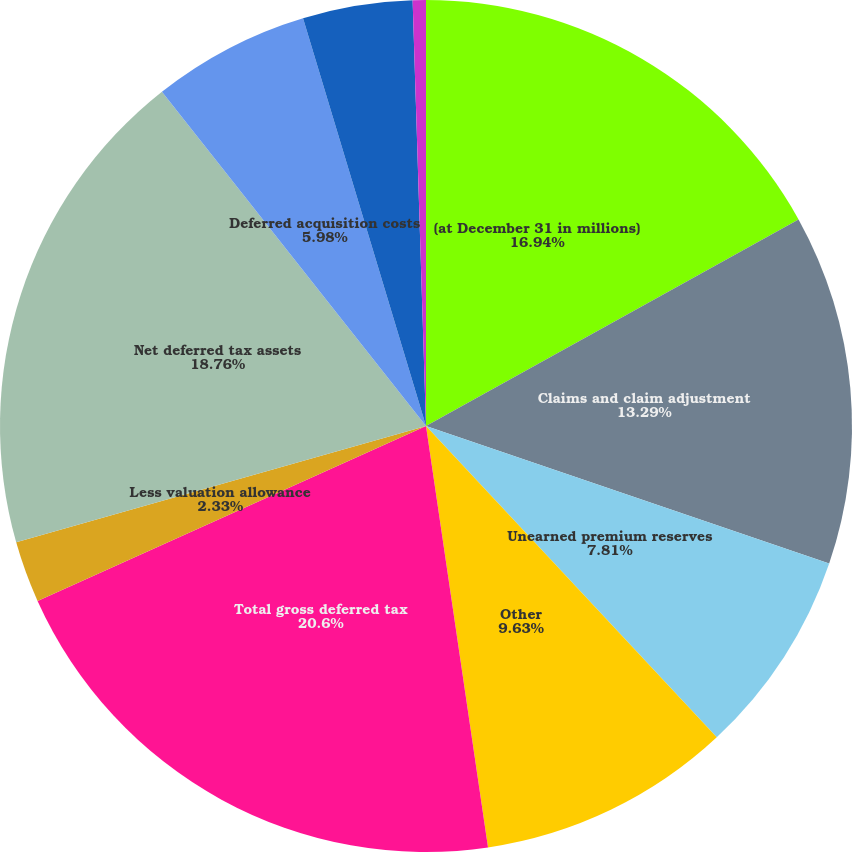Convert chart to OTSL. <chart><loc_0><loc_0><loc_500><loc_500><pie_chart><fcel>(at December 31 in millions)<fcel>Claims and claim adjustment<fcel>Unearned premium reserves<fcel>Other<fcel>Total gross deferred tax<fcel>Less valuation allowance<fcel>Net deferred tax assets<fcel>Deferred acquisition costs<fcel>Investments<fcel>Internally-developed software<nl><fcel>16.94%<fcel>13.29%<fcel>7.81%<fcel>9.63%<fcel>20.59%<fcel>2.33%<fcel>18.76%<fcel>5.98%<fcel>4.16%<fcel>0.5%<nl></chart> 